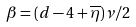Convert formula to latex. <formula><loc_0><loc_0><loc_500><loc_500>\beta = ( d - 4 + \overline { \eta } ) \nu / 2</formula> 